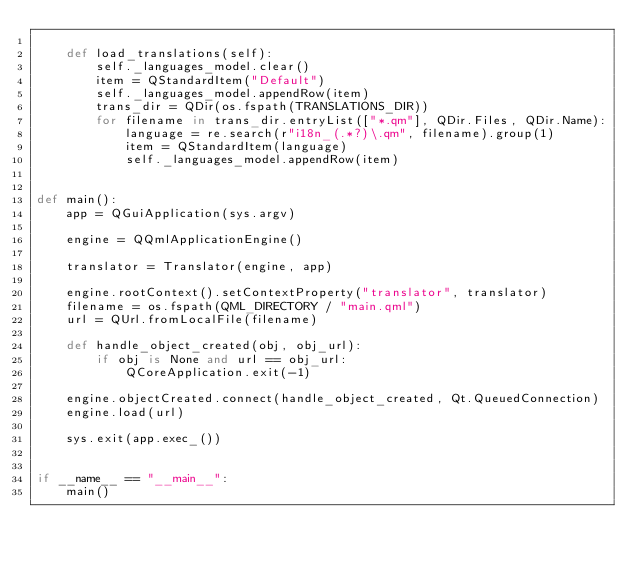Convert code to text. <code><loc_0><loc_0><loc_500><loc_500><_Python_>
    def load_translations(self):
        self._languages_model.clear()
        item = QStandardItem("Default")
        self._languages_model.appendRow(item)
        trans_dir = QDir(os.fspath(TRANSLATIONS_DIR))
        for filename in trans_dir.entryList(["*.qm"], QDir.Files, QDir.Name):
            language = re.search(r"i18n_(.*?)\.qm", filename).group(1)
            item = QStandardItem(language)
            self._languages_model.appendRow(item)


def main():
    app = QGuiApplication(sys.argv)

    engine = QQmlApplicationEngine()

    translator = Translator(engine, app)

    engine.rootContext().setContextProperty("translator", translator)
    filename = os.fspath(QML_DIRECTORY / "main.qml")
    url = QUrl.fromLocalFile(filename)

    def handle_object_created(obj, obj_url):
        if obj is None and url == obj_url:
            QCoreApplication.exit(-1)

    engine.objectCreated.connect(handle_object_created, Qt.QueuedConnection)
    engine.load(url)

    sys.exit(app.exec_())


if __name__ == "__main__":
    main()
</code> 